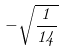Convert formula to latex. <formula><loc_0><loc_0><loc_500><loc_500>- \sqrt { \frac { 1 } { 1 4 } }</formula> 